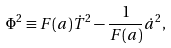Convert formula to latex. <formula><loc_0><loc_0><loc_500><loc_500>\Phi ^ { 2 } \equiv F ( a ) \dot { T } ^ { 2 } - \frac { 1 } { F ( a ) } \dot { a } ^ { 2 } ,</formula> 